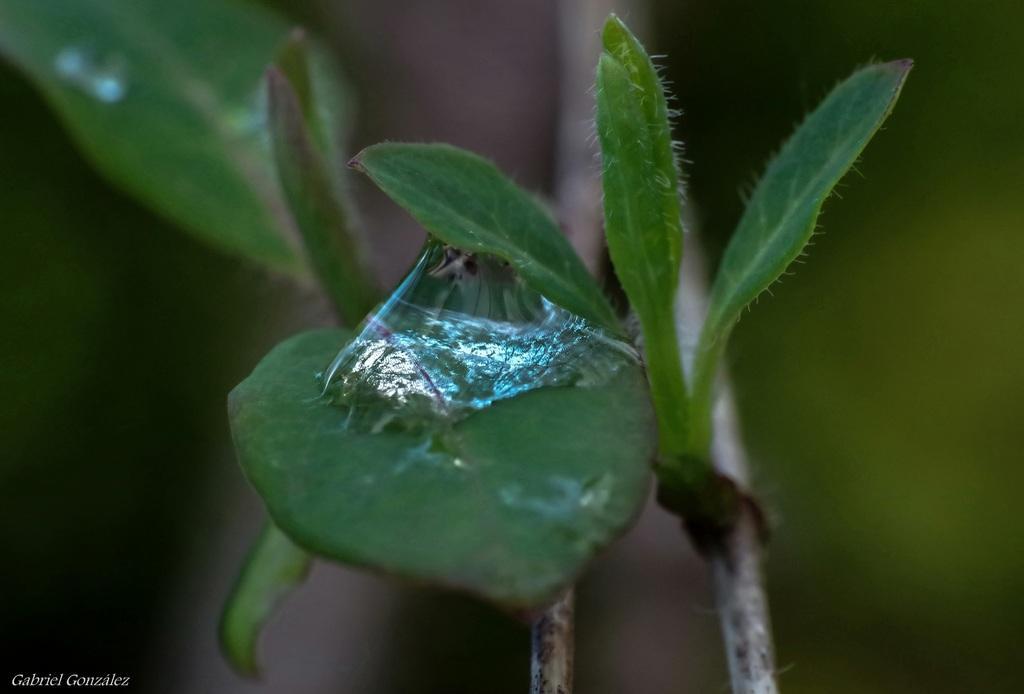How would you summarize this image in a sentence or two? In this picture we can see some sticky substance on a leaf. There are a few leaves and stems are visible. Background is blurry. There is some text in the bottom left. 